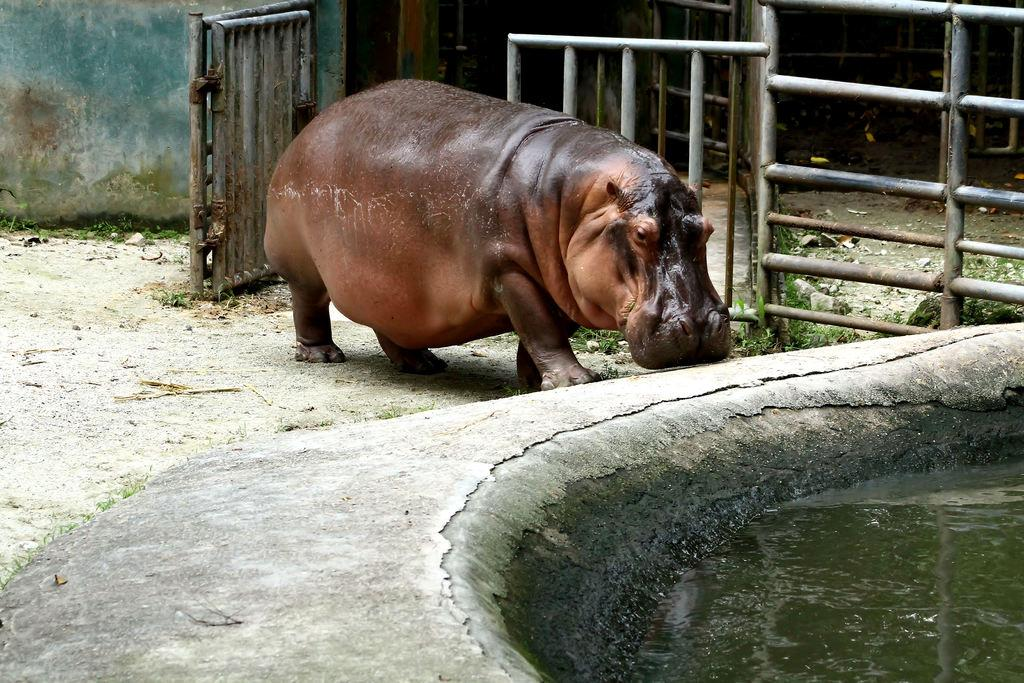What animal is present in the image? There is a hippopotamus in the image. What can be seen at the right bottom of the image? There is water visible at the right bottom of the image. What type of structure is in the image? There is a gate in the image. What is visible in the background of the image? There is a wall in the background of the image. What type of recess can be seen in the image? There is no recess present in the image. Who is the partner of the hippopotamus in the image? The image does not depict any relationships between animals, so there is no partner for the hippopotamus. 